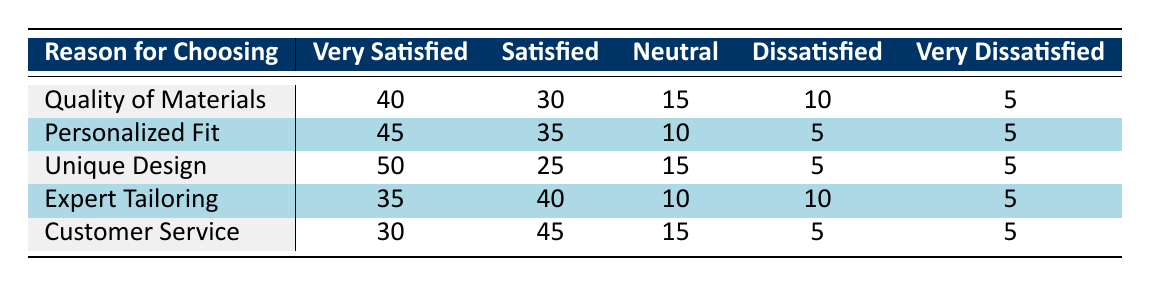What is the satisfaction rating for "Unique Design" in the "Very Satisfied" category? The table shows that for "Unique Design," the count in the "Very Satisfied" category is listed directly as 50.
Answer: 50 Which reason for choosing custom tailoring has the highest number of "Dissatisfied" responses? By looking at the "Dissatisfied" column, we see that both "Quality of Materials" and "Expert Tailoring" have 10 responses, which is the highest.
Answer: Quality of Materials and Expert Tailoring What is the average number of "Satisfied" ratings across all reasons? Adding the "Satisfied" values gives us (30 + 35 + 25 + 40 + 45) = 175. There are 5 reasons, so the average is 175 / 5 = 35.
Answer: 35 Is it true that "Customer Service" has fewer "Very Satisfied" responses than "Personalized Fit"? "Customer Service" has 30 "Very Satisfied" responses, while "Personalized Fit" has 45. Since 30 is less than 45, the statement is true.
Answer: Yes What is the total number of "Neutral" ratings across all options? Adding the "Neutral" values gives us (15 + 10 + 15 + 10 + 15) = 65.
Answer: 65 Which reason has the lowest combined score of "Dissatisfied" and "Very Dissatisfied"? For "Customer Service," the scores are (5 + 5) = 10, which is the lowest compared to other reasons.
Answer: Customer Service How do the "Very Satisfied" ratings compare between "Expert Tailoring" and "Quality of Materials"? "Expert Tailoring" has 35, while "Quality of Materials" has 40. Therefore, "Quality of Materials" has a higher "Very Satisfied" rating by 5.
Answer: Quality of Materials has 5 more What is the ratio of "Very Dissatisfied" to "Satisfied" ratings for "Personalized Fit"? For "Personalized Fit," the "Very Dissatisfied" count is 5 and the "Satisfied" count is 35. The ratio is 5 to 35, which simplifies to 1 to 7.
Answer: 1 to 7 